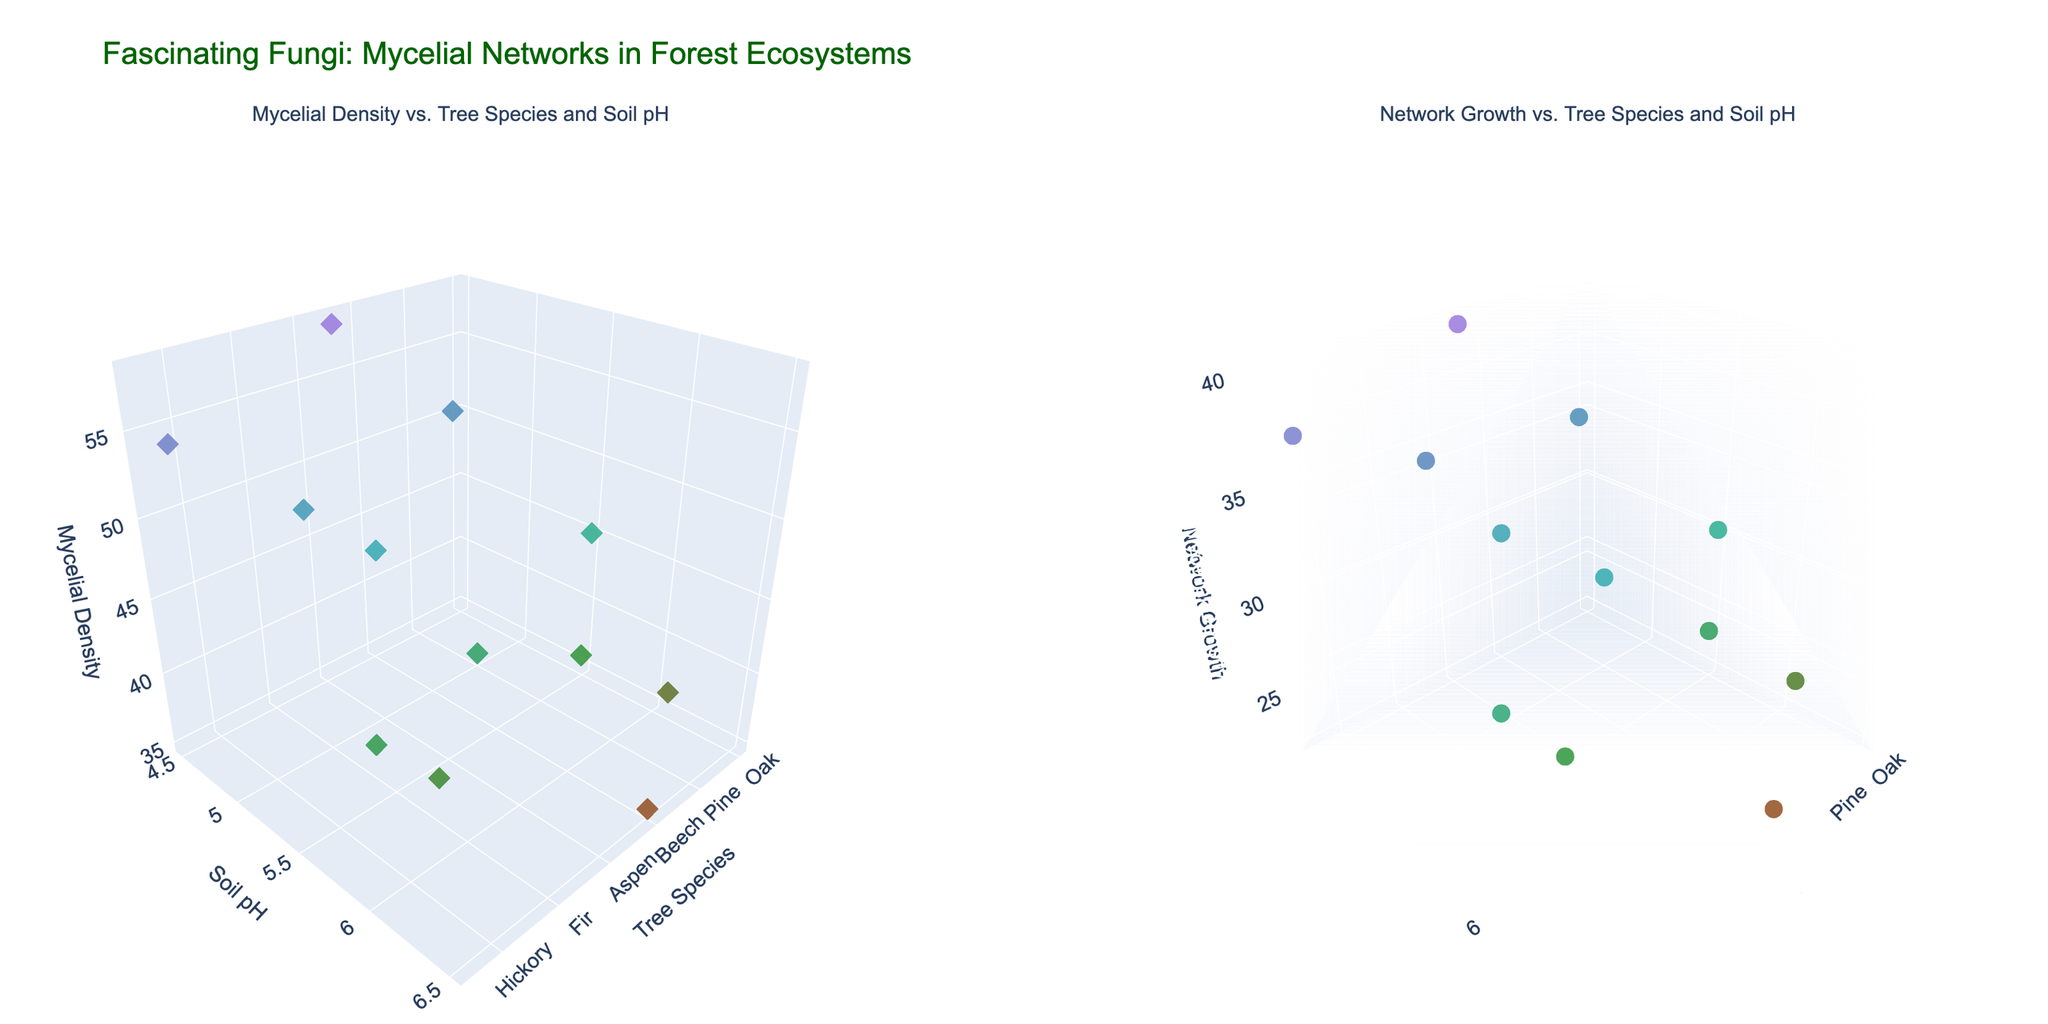Where is the soil pH lowest for Mycelial Density? The soil pH is indicated on the y-axis of the first subplot. Look for the data point with the lowest y-value in the subplot focused on Mycelial Density.
Answer: Spruce Which tree species has the highest Network Growth? Examine the second subplot where the z-axis represents Network Growth. Identify the data point with the greatest z-value.
Answer: Spruce How does Mycelial Density compare between Oak and Maple tree species? In the first subplot, locate the z-values for Oak and Maple along the x-axis. Compare their heights to see which is higher.
Answer: Oak > Maple What's the average soil pH for trees with a Network Growth greater than 30? In the second subplot, find the tree species with Network Growth values greater than 30. Note their soil pH values and calculate the average.
Answer: 5.2 (Aspen, Cedar, Fir, Hemlock, Pine, and Spruce) Which tree species shows the closest Mycelial Density to 50? Look in the first subplot where the z-values represent Mycelial Density. Find the point closest to a z-value of 50.
Answer: Fir Is there any tree species with an approximately equal Mycelial Density and Network Growth? Compare both subplots side by side, looking for a tree species where the z-values (height) in both plots are similar.
Answer: Cedar What is the Mycelial Density for trees with soil pH between 5.5 and 6.0? Look at the first subplot and identify the points where the y-values (soil pH) are between 5.5 and 6.0. Record their z-values (Mycelial Density).
Answer: Oak: 45, Birch: 41, Aspen: 43, Elm: 40, Hickory: 42 If the soil pH is increased, what is the general trend in Network Growth? Observe the second subplot and look at the pattern formed by the data points as the y-value (soil pH) increases.
Answer: Generally decreases What's the difference in Network Growth between Spruce and Hemlock? Identify the z-values for Spruce and Hemlock in the second subplot and subtract Hemlock's value from Spruce's value.
Answer: 2 Which subplot shows greater variation in z-values among tree species? Compare the range of z-values (heights of dots) between the two subplots, assessing which has a larger spread.
Answer: Second subplot (Network Growth) 